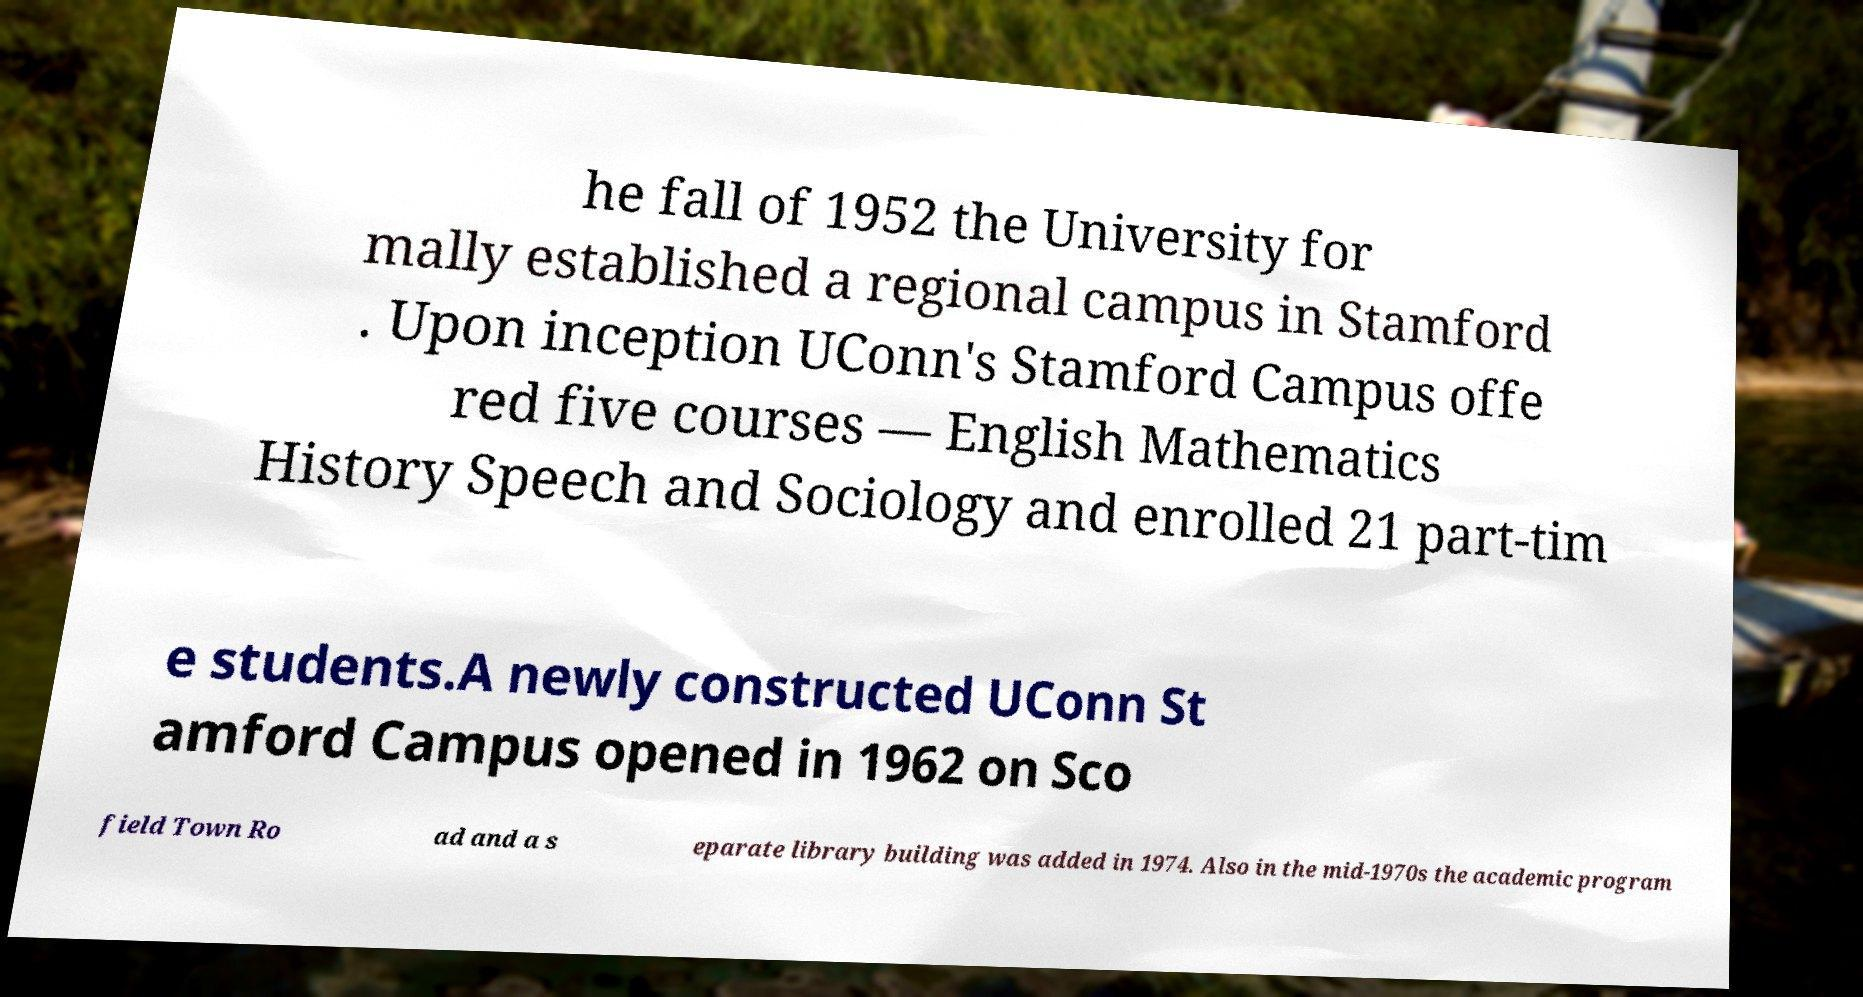What messages or text are displayed in this image? I need them in a readable, typed format. he fall of 1952 the University for mally established a regional campus in Stamford . Upon inception UConn's Stamford Campus offe red five courses — English Mathematics History Speech and Sociology and enrolled 21 part-tim e students.A newly constructed UConn St amford Campus opened in 1962 on Sco field Town Ro ad and a s eparate library building was added in 1974. Also in the mid-1970s the academic program 